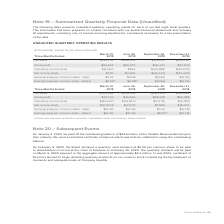According to Adtran's financial document, What was the net sales in Three Months Ended March 31, 2019? According to the financial document, $143,791 (in thousands). The relevant text states: "Net sales $143,791 $156,391 $114,092 $115,787..." Also, What was the Gross Profit in Three Months Ended June 30, 2019? According to the financial document, $65,015 (in thousands). The relevant text states: "Gross profit $60,612 $65,015 $46,331 $47,209..." Also, What does the table show? UNAUDITED QUARTERLY OPERATING RESULTS. The document states: "The following table presents unaudited quarterly operating results for each of our last eight fiscal quarters. This information has been prepared on a..." Also, can you calculate: What is the total net sales of the 3 highest earning quarters in 2019? Based on the calculation:  $143,791 + $156,391 + $115,787 , the result is 415969 (in thousands). This is based on the information: "Net sales $143,791 $156,391 $114,092 $115,787 Net sales $143,791 $156,391 $114,092 $115,787 Net sales $143,791 $156,391 $114,092 $115,787..." The key data points involved are: 115,787, 143,791, 156,391. Also, can you calculate: What was the change in gross profit between  Three Months Ended  March 31, 2019 and June 30, 2019? Based on the calculation: $65,015-$60,612, the result is 4403 (in thousands). This is based on the information: "Gross profit $60,612 $65,015 $46,331 $47,209 Gross profit $60,612 $65,015 $46,331 $47,209..." The key data points involved are: 60,612, 65,015. Also, can you calculate: What was the percentage change in Net sales between Three Months Ended  September and December in 2019? To answer this question, I need to perform calculations using the financial data. The calculation is: ( $115,787 - $114,092 )/ $114,092 , which equals 1.49 (percentage). This is based on the information: "Net sales $143,791 $156,391 $114,092 $115,787 Net sales $143,791 $156,391 $114,092 $115,787..." The key data points involved are: 114,092, 115,787. 